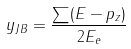Convert formula to latex. <formula><loc_0><loc_0><loc_500><loc_500>y _ { J B } = \frac { \sum ( E - p _ { z } ) } { 2 E _ { e } }</formula> 